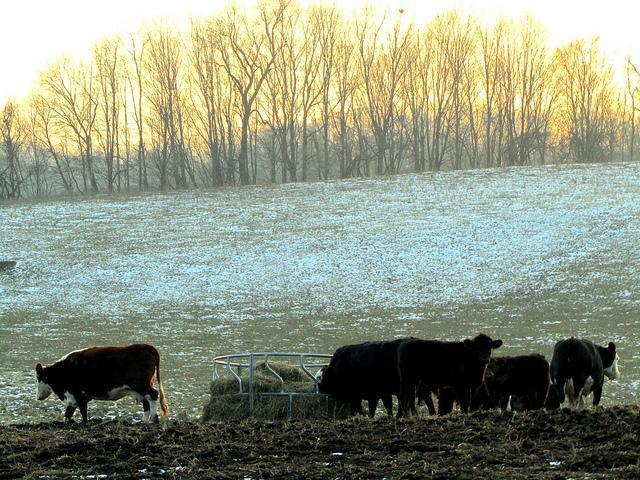What weather event happened recently?
Choose the correct response and explain in the format: 'Answer: answer
Rationale: rationale.'
Options: Rain, hail, flash flood, snow. Answer: snow.
Rationale: You can see the sprinkling of light snowflakes on the ground. 